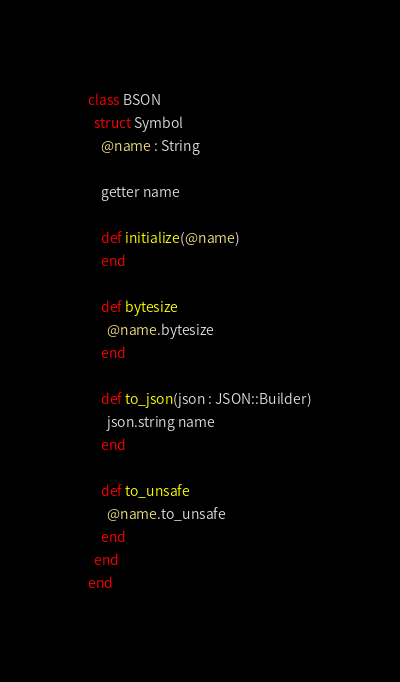Convert code to text. <code><loc_0><loc_0><loc_500><loc_500><_Crystal_>class BSON
  struct Symbol
    @name : String

    getter name

    def initialize(@name)
    end

    def bytesize
      @name.bytesize
    end

    def to_json(json : JSON::Builder)
      json.string name
    end

    def to_unsafe
      @name.to_unsafe
    end
  end
end
</code> 